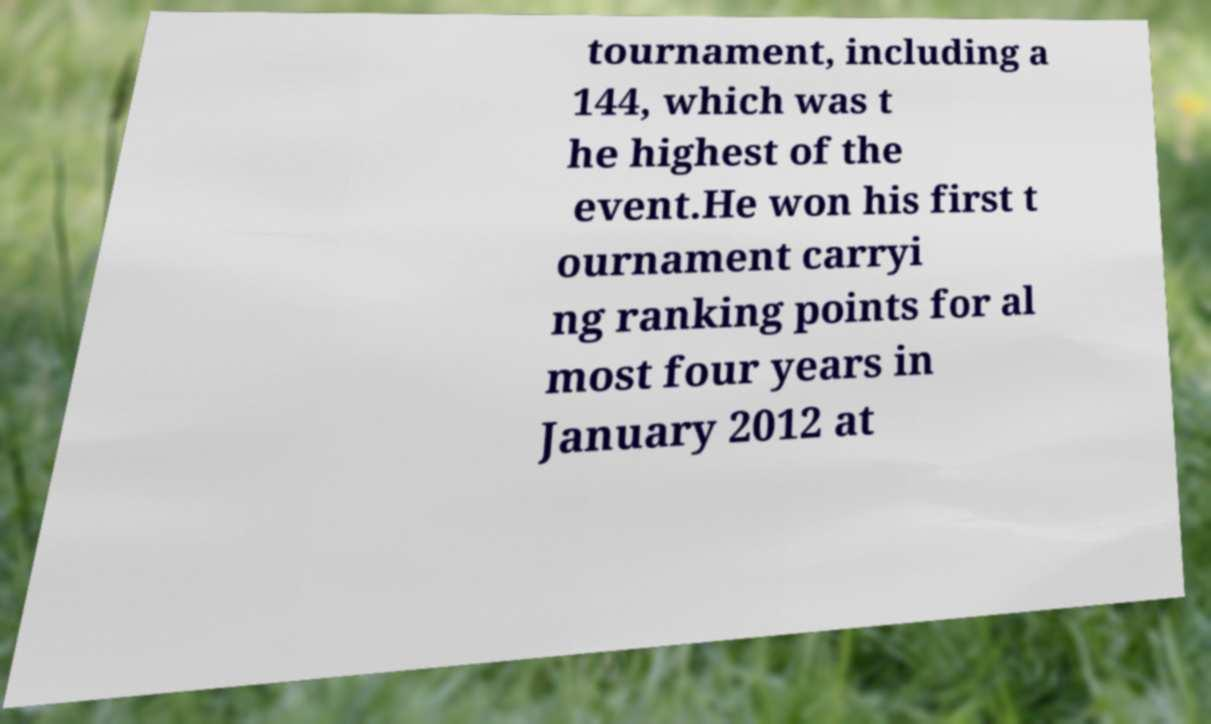I need the written content from this picture converted into text. Can you do that? tournament, including a 144, which was t he highest of the event.He won his first t ournament carryi ng ranking points for al most four years in January 2012 at 